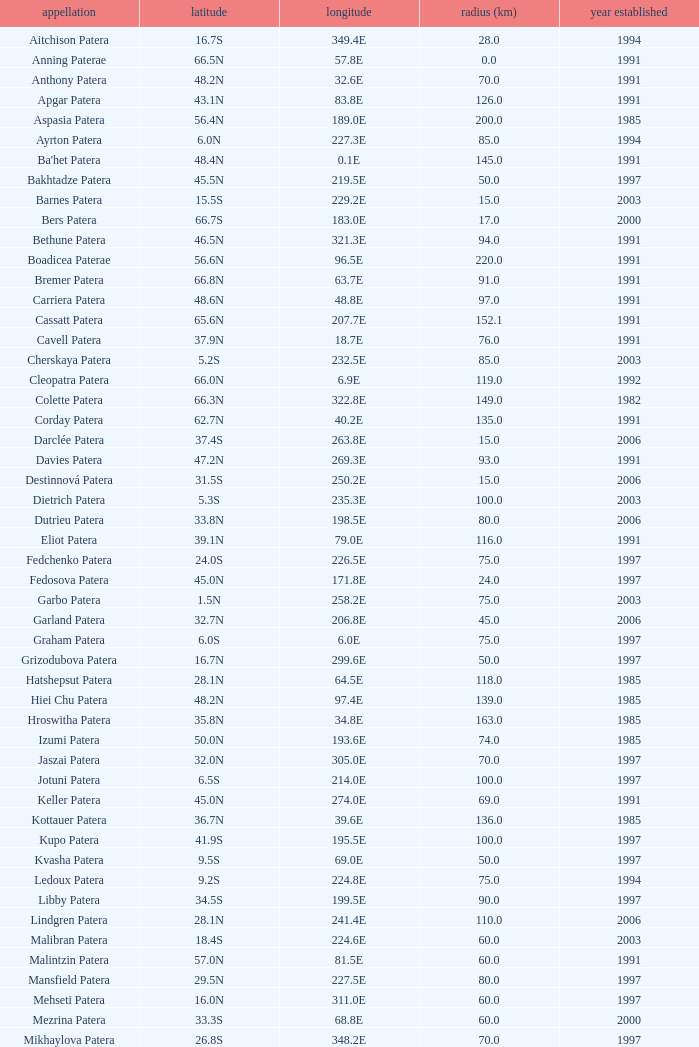What is Longitude, when Name is Raskova Paterae? 222.8E. 